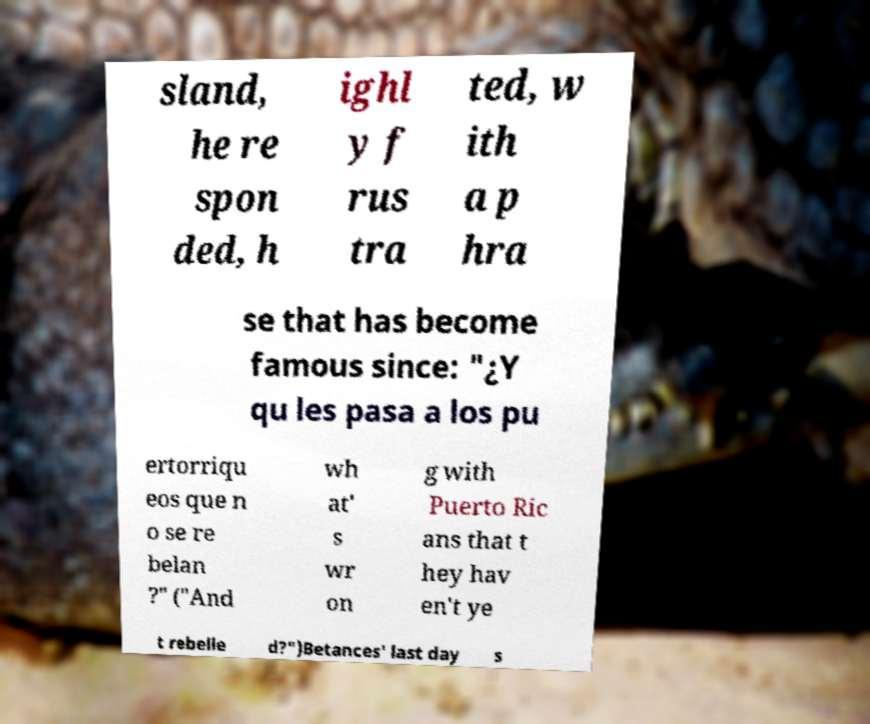Please identify and transcribe the text found in this image. sland, he re spon ded, h ighl y f rus tra ted, w ith a p hra se that has become famous since: "¿Y qu les pasa a los pu ertorriqu eos que n o se re belan ?" ("And wh at' s wr on g with Puerto Ric ans that t hey hav en't ye t rebelle d?")Betances' last day s 